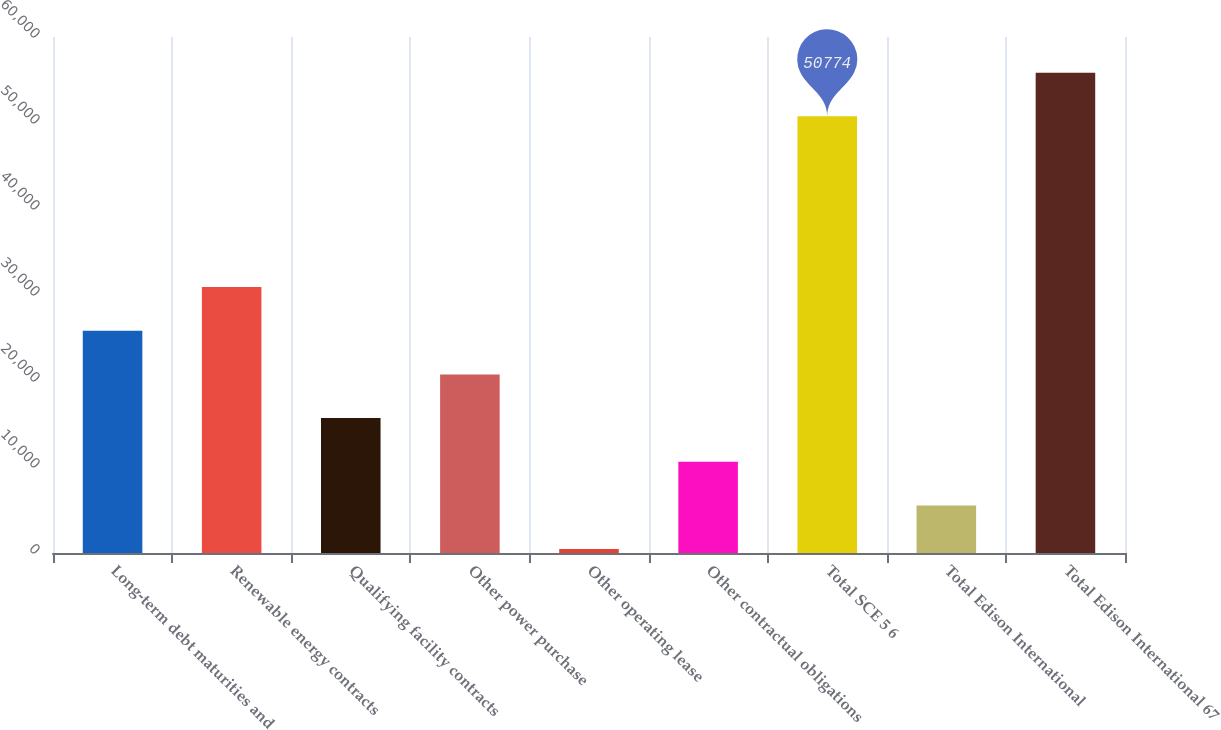Convert chart. <chart><loc_0><loc_0><loc_500><loc_500><bar_chart><fcel>Long-term debt maturities and<fcel>Renewable energy contracts<fcel>Qualifying facility contracts<fcel>Other power purchase<fcel>Other operating lease<fcel>Other contractual obligations<fcel>Total SCE 5 6<fcel>Total Edison International<fcel>Total Edison International 67<nl><fcel>25843.5<fcel>30921.6<fcel>15687.3<fcel>20765.4<fcel>453<fcel>10609.2<fcel>50774<fcel>5531.1<fcel>55852.1<nl></chart> 